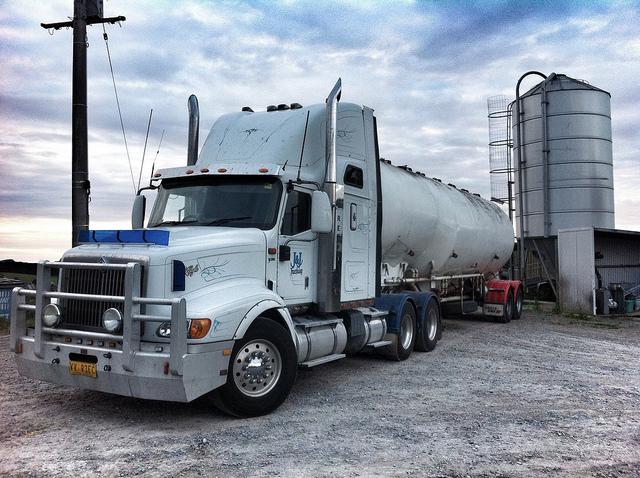What color is the truck?
Be succinct. White. Is this truck transporting animals?
Concise answer only. No. What is behind the truck?
Short answer required. Silo. 